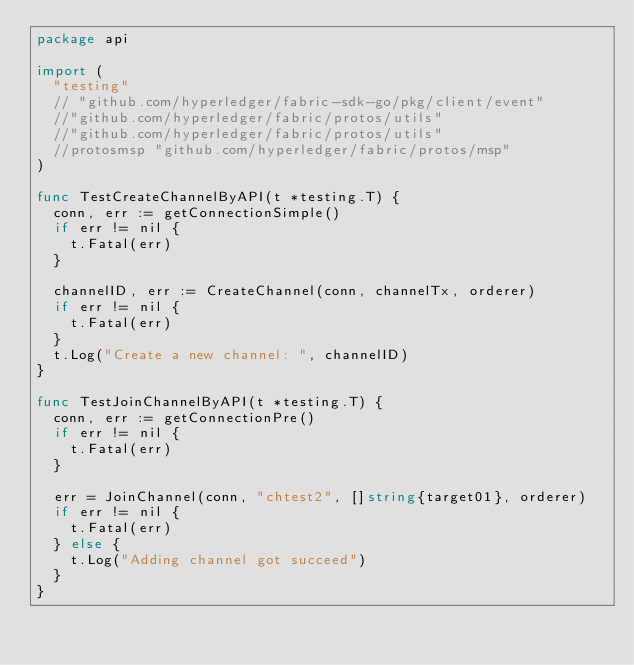Convert code to text. <code><loc_0><loc_0><loc_500><loc_500><_Go_>package api

import (
	"testing"
	// "github.com/hyperledger/fabric-sdk-go/pkg/client/event"
	//"github.com/hyperledger/fabric/protos/utils"
	//"github.com/hyperledger/fabric/protos/utils"
	//protosmsp "github.com/hyperledger/fabric/protos/msp"
)

func TestCreateChannelByAPI(t *testing.T) {
	conn, err := getConnectionSimple()
	if err != nil {
		t.Fatal(err)
	}

	channelID, err := CreateChannel(conn, channelTx, orderer)
	if err != nil {
		t.Fatal(err)
	}
	t.Log("Create a new channel: ", channelID)
}

func TestJoinChannelByAPI(t *testing.T) {
	conn, err := getConnectionPre()
	if err != nil {
		t.Fatal(err)
	}

	err = JoinChannel(conn, "chtest2", []string{target01}, orderer)
	if err != nil {
		t.Fatal(err)
	} else {
		t.Log("Adding channel got succeed")
	}
}
</code> 